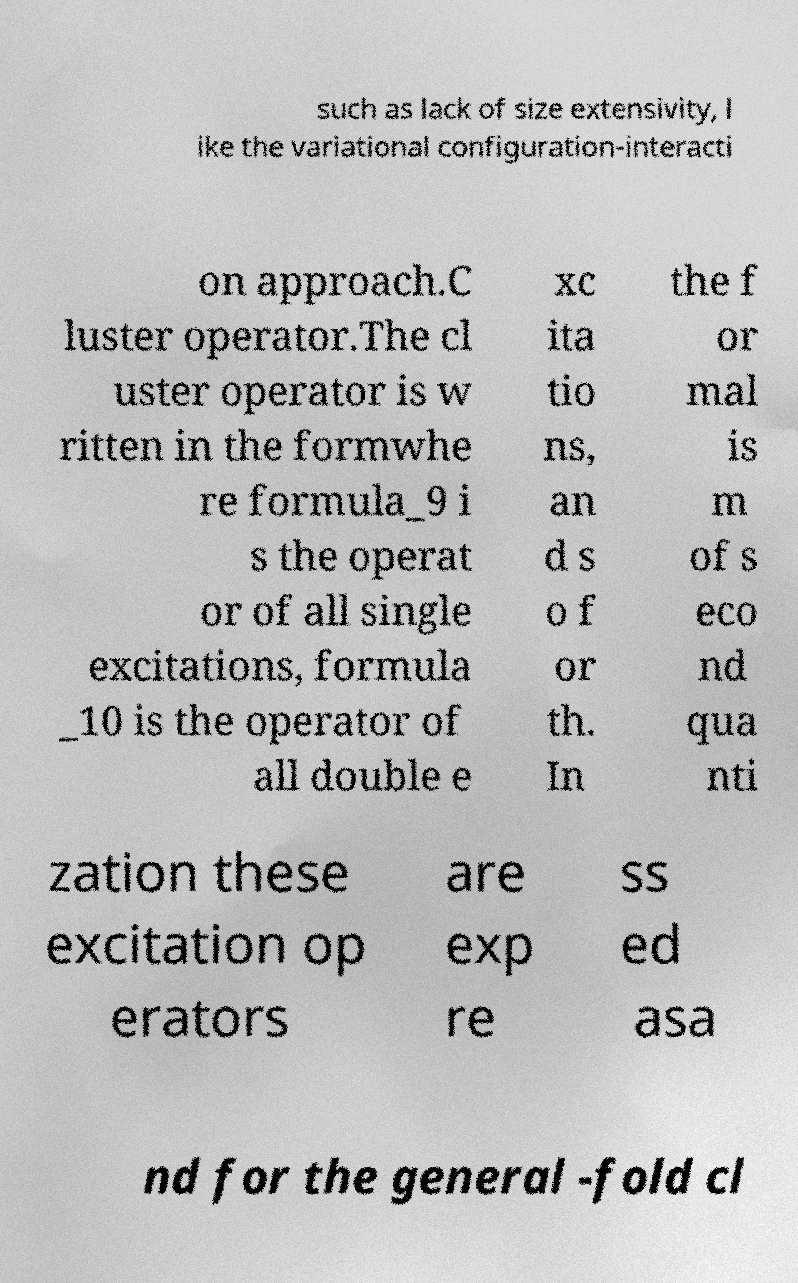What messages or text are displayed in this image? I need them in a readable, typed format. such as lack of size extensivity, l ike the variational configuration-interacti on approach.C luster operator.The cl uster operator is w ritten in the formwhe re formula_9 i s the operat or of all single excitations, formula _10 is the operator of all double e xc ita tio ns, an d s o f or th. In the f or mal is m of s eco nd qua nti zation these excitation op erators are exp re ss ed asa nd for the general -fold cl 